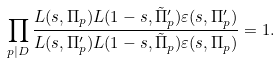<formula> <loc_0><loc_0><loc_500><loc_500>\prod _ { p | D } \frac { L ( s , \Pi _ { p } ) L ( 1 - s , \tilde { \Pi } ^ { \prime } _ { p } ) \varepsilon ( s , \Pi ^ { \prime } _ { p } ) } { L ( s , \Pi ^ { \prime } _ { p } ) L ( 1 - s , \tilde { \Pi } _ { p } ) \varepsilon ( s , \Pi _ { p } ) } = 1 .</formula> 